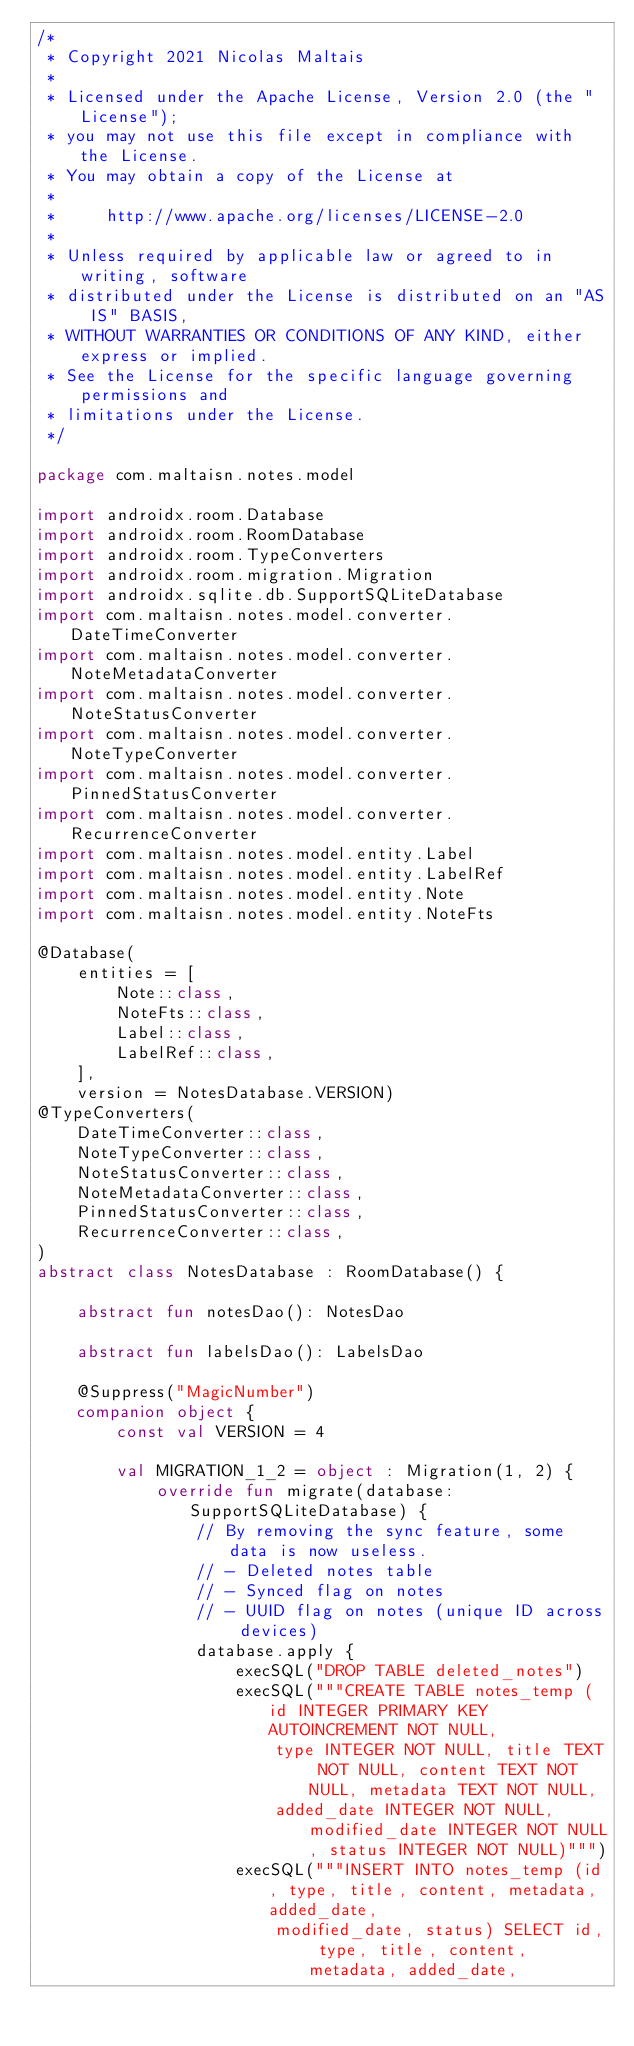<code> <loc_0><loc_0><loc_500><loc_500><_Kotlin_>/*
 * Copyright 2021 Nicolas Maltais
 *
 * Licensed under the Apache License, Version 2.0 (the "License");
 * you may not use this file except in compliance with the License.
 * You may obtain a copy of the License at
 *
 *     http://www.apache.org/licenses/LICENSE-2.0
 *
 * Unless required by applicable law or agreed to in writing, software
 * distributed under the License is distributed on an "AS IS" BASIS,
 * WITHOUT WARRANTIES OR CONDITIONS OF ANY KIND, either express or implied.
 * See the License for the specific language governing permissions and
 * limitations under the License.
 */

package com.maltaisn.notes.model

import androidx.room.Database
import androidx.room.RoomDatabase
import androidx.room.TypeConverters
import androidx.room.migration.Migration
import androidx.sqlite.db.SupportSQLiteDatabase
import com.maltaisn.notes.model.converter.DateTimeConverter
import com.maltaisn.notes.model.converter.NoteMetadataConverter
import com.maltaisn.notes.model.converter.NoteStatusConverter
import com.maltaisn.notes.model.converter.NoteTypeConverter
import com.maltaisn.notes.model.converter.PinnedStatusConverter
import com.maltaisn.notes.model.converter.RecurrenceConverter
import com.maltaisn.notes.model.entity.Label
import com.maltaisn.notes.model.entity.LabelRef
import com.maltaisn.notes.model.entity.Note
import com.maltaisn.notes.model.entity.NoteFts

@Database(
    entities = [
        Note::class,
        NoteFts::class,
        Label::class,
        LabelRef::class,
    ],
    version = NotesDatabase.VERSION)
@TypeConverters(
    DateTimeConverter::class,
    NoteTypeConverter::class,
    NoteStatusConverter::class,
    NoteMetadataConverter::class,
    PinnedStatusConverter::class,
    RecurrenceConverter::class,
)
abstract class NotesDatabase : RoomDatabase() {

    abstract fun notesDao(): NotesDao

    abstract fun labelsDao(): LabelsDao

    @Suppress("MagicNumber")
    companion object {
        const val VERSION = 4

        val MIGRATION_1_2 = object : Migration(1, 2) {
            override fun migrate(database: SupportSQLiteDatabase) {
                // By removing the sync feature, some data is now useless.
                // - Deleted notes table
                // - Synced flag on notes
                // - UUID flag on notes (unique ID across devices)
                database.apply {
                    execSQL("DROP TABLE deleted_notes")
                    execSQL("""CREATE TABLE notes_temp (id INTEGER PRIMARY KEY AUTOINCREMENT NOT NULL, 
                        type INTEGER NOT NULL, title TEXT NOT NULL, content TEXT NOT NULL, metadata TEXT NOT NULL, 
                        added_date INTEGER NOT NULL, modified_date INTEGER NOT NULL, status INTEGER NOT NULL)""")
                    execSQL("""INSERT INTO notes_temp (id, type, title, content, metadata, added_date, 
                        modified_date, status) SELECT id, type, title, content, metadata, added_date,</code> 